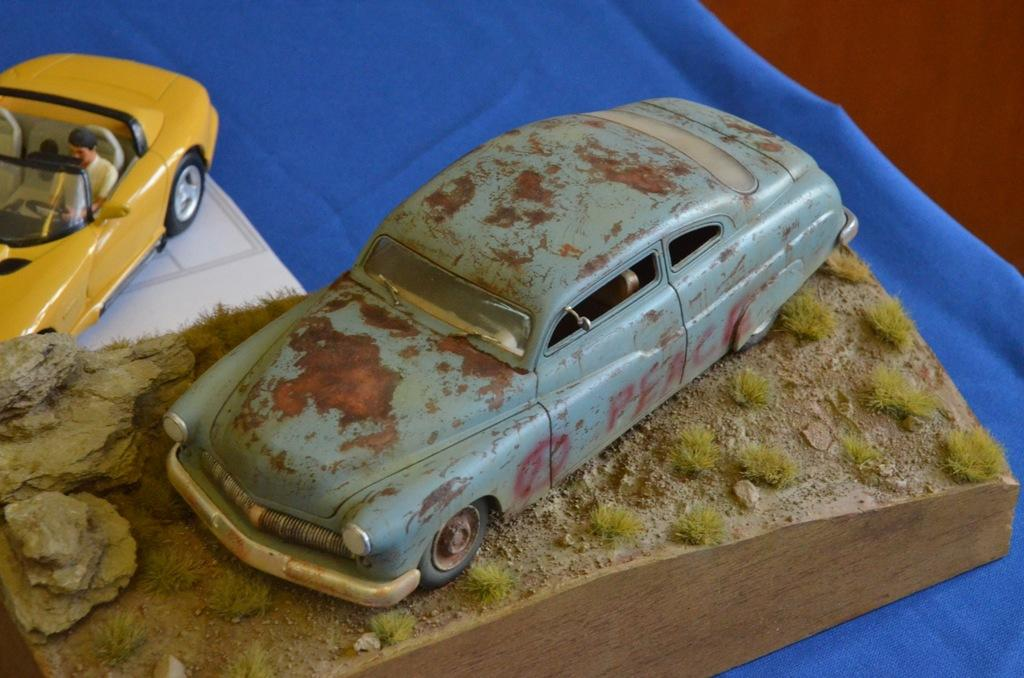What objects are present in the image? There are two car toys in the image. What is the car toys placed on? The car toys are on a blue cloth. How many pets are visible in the image? There are no pets visible in the image; it only features two car toys on a blue cloth. What type of bird can be seen flying in the image? There is no bird present in the image. 